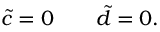<formula> <loc_0><loc_0><loc_500><loc_500>\tilde { c } = 0 \quad \tilde { d } = 0 .</formula> 